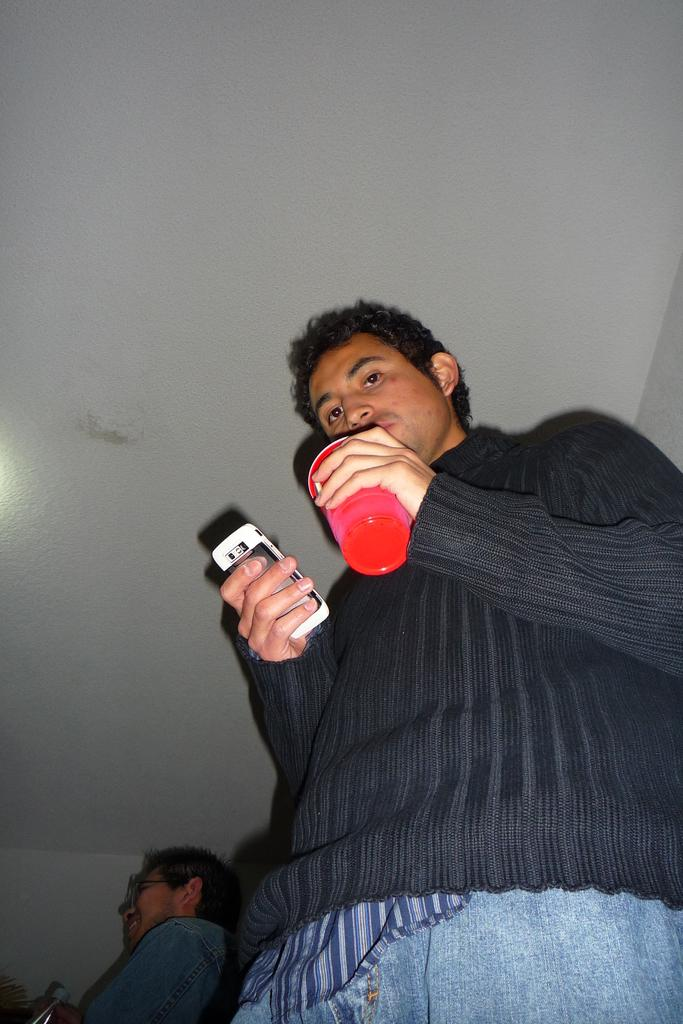What is the person in the image wearing? The person in the image is wearing a black dress. What is the person holding in their hands? The person is holding a bottle and a mobile. Can you describe the person's surroundings? There is another guy behind the person in the black dress, and there is a ceiling visible in the image. What type of balls are being used to support the person in the image? There are no balls present in the image, and the person is not being supported by any objects. 